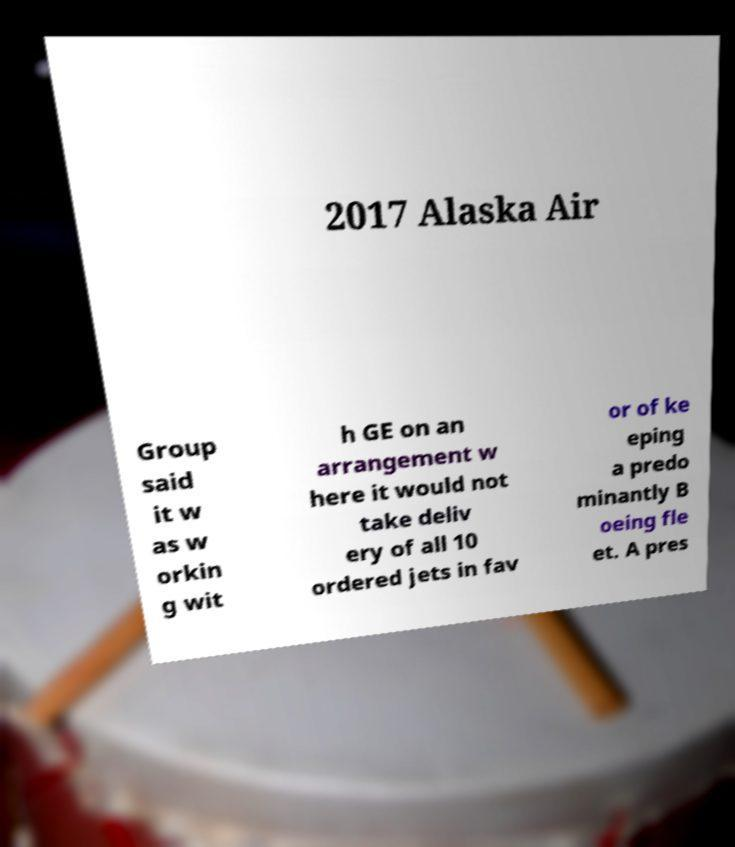For documentation purposes, I need the text within this image transcribed. Could you provide that? 2017 Alaska Air Group said it w as w orkin g wit h GE on an arrangement w here it would not take deliv ery of all 10 ordered jets in fav or of ke eping a predo minantly B oeing fle et. A pres 